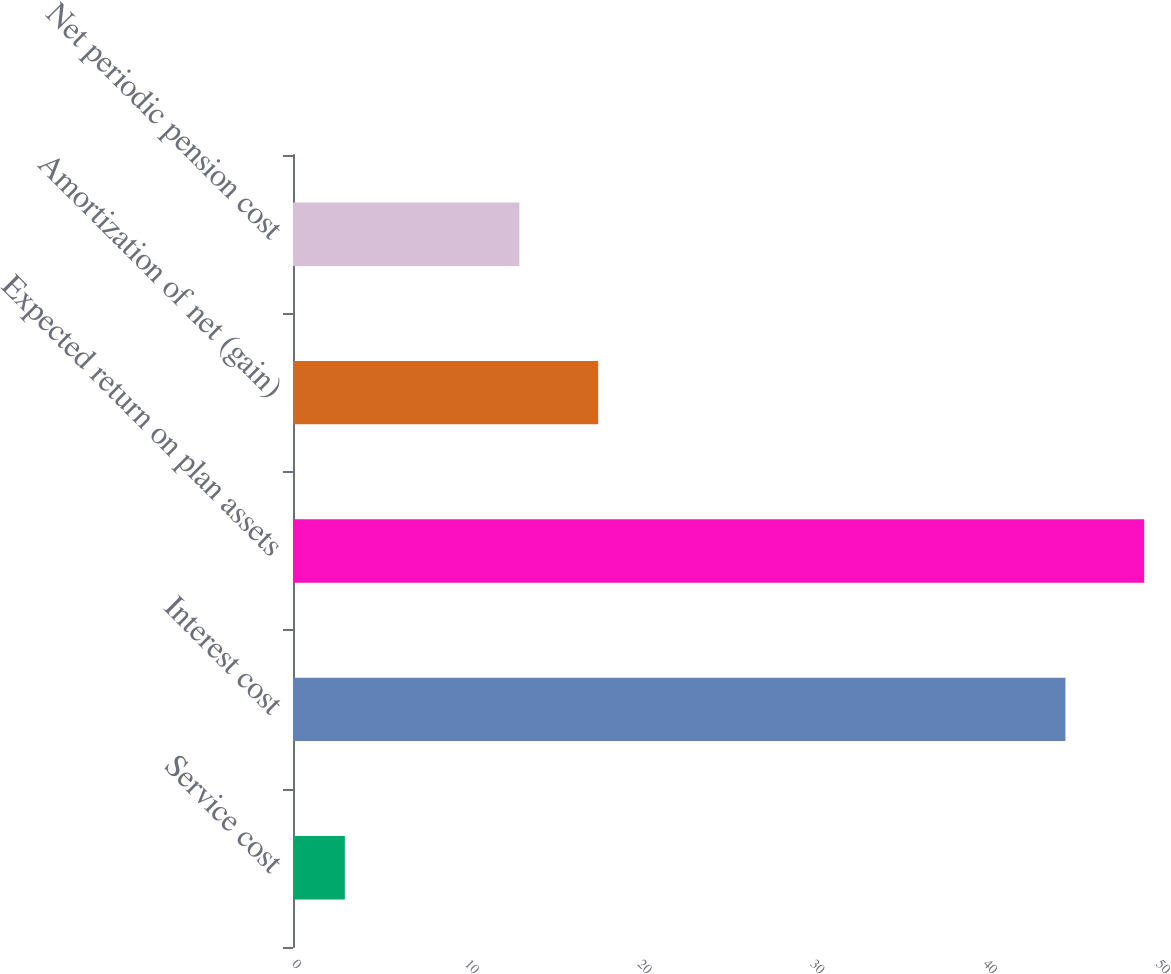<chart> <loc_0><loc_0><loc_500><loc_500><bar_chart><fcel>Service cost<fcel>Interest cost<fcel>Expected return on plan assets<fcel>Amortization of net (gain)<fcel>Net periodic pension cost<nl><fcel>3<fcel>44.7<fcel>49.26<fcel>17.66<fcel>13.1<nl></chart> 